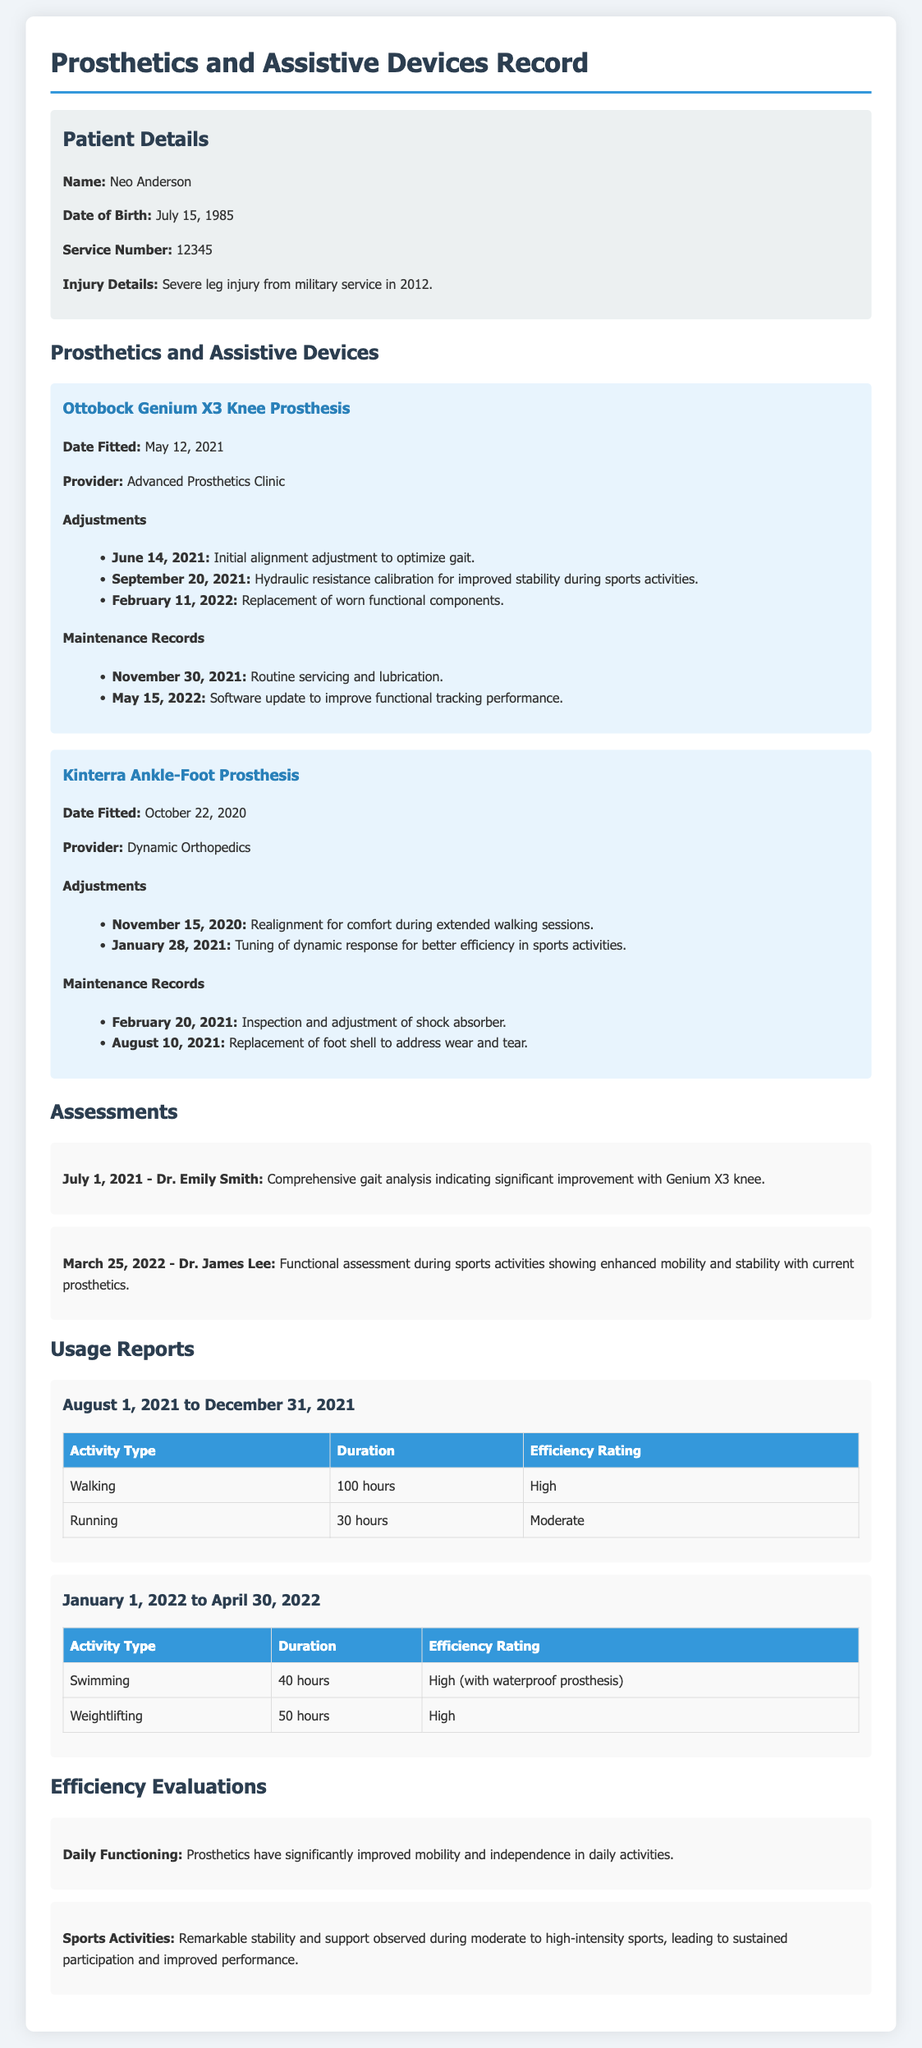What is the name of the knee prosthesis? The knee prosthesis mentioned in the document is called the Ottobock Genium X3 Knee Prosthesis.
Answer: Ottobock Genium X3 Knee Prosthesis What date was the Kinterra Ankle-Foot Prosthesis fitted? The fitting date for the Kinterra Ankle-Foot Prosthesis is provided in the document as October 22, 2020.
Answer: October 22, 2020 Who performed the comprehensive gait analysis? The comprehensive gait analysis was conducted by Dr. Emily Smith on July 1, 2021.
Answer: Dr. Emily Smith What adjustment was made on February 11, 2022? The adjustment made on February 11, 2022, involved the replacement of worn functional components for the Ottobock Genium X3 Knee Prosthesis.
Answer: Replacement of worn functional components How many hours were spent running from August 1, 2021 to December 31, 2021? The document states that there were 30 hours spent running during the specified period.
Answer: 30 hours What provider fitted the Ottobock Genium X3 Knee Prosthesis? The provider who fitted the Ottobock Genium X3 Knee Prosthesis is mentioned as Advanced Prosthetics Clinic.
Answer: Advanced Prosthetics Clinic What is the efficiency rating for swimming with the waterproof prosthesis? The efficiency rating for swimming with the waterproof prosthesis is rated as High.
Answer: High How has the prosthetics affected daily functioning according to the evaluation? The evaluation notes that the prosthetics have significantly improved mobility and independence in daily activities.
Answer: Significantly improved mobility and independence What is the primary purpose of the document? The document serves as a record for tracking the fitting, adjustments, and maintenance of prosthetics and assistive devices, alongside assessments and usage reports.
Answer: Tracking prosthetics and assistive devices 